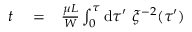Convert formula to latex. <formula><loc_0><loc_0><loc_500><loc_500>\begin{array} { r l r } { t } & = } & { \frac { \mu L } { W } \int _ { 0 } ^ { \tau } d \tau ^ { \prime } \ \xi ^ { - 2 } ( \tau ^ { \prime } ) } \end{array}</formula> 